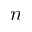Convert formula to latex. <formula><loc_0><loc_0><loc_500><loc_500>n</formula> 